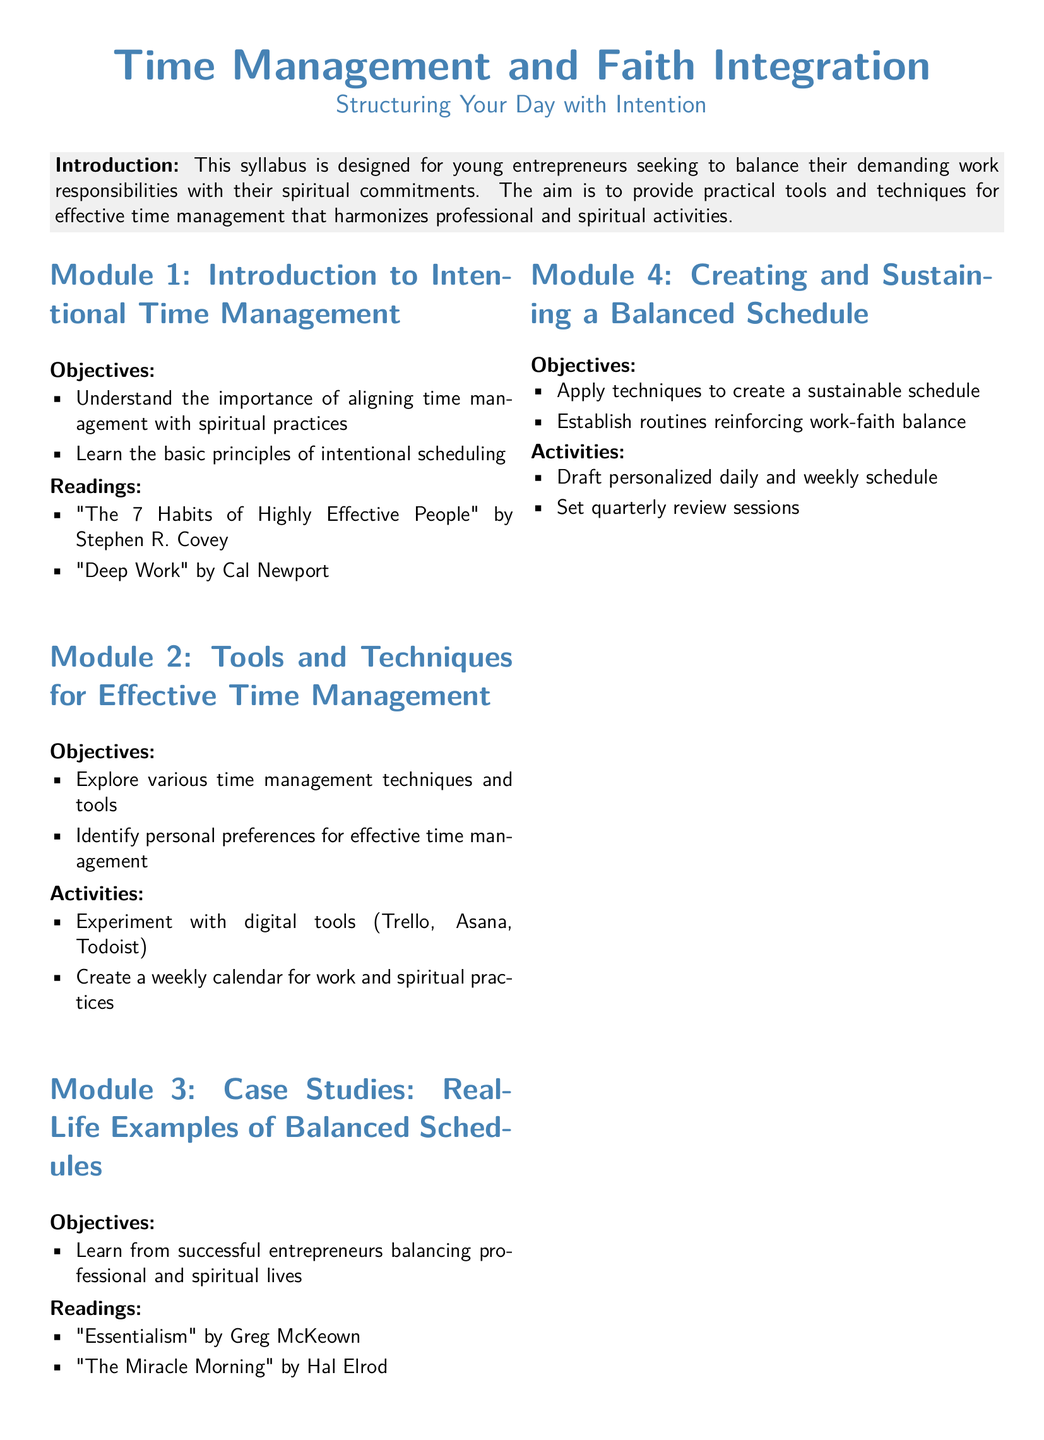what is the title of Module 4? The title is provided in the syllabus under the section headings, which states "Creating and Sustaining a Balanced Schedule."
Answer: Creating and Sustaining a Balanced Schedule how many modules are listed in the syllabus? The syllabus outlines a total of four modules, as indicated by the numbered sections.
Answer: 4 what is one of the objectives of Module 1? The syllabus lists objectives in bullet points for each module, with one objective stating, "Understand the importance of aligning time management with spiritual practices."
Answer: Understand the importance of aligning time management with spiritual practices which reading is suggested for Module 3? The readings for each module are explicitly listed, and one suggested reading for Module 3 is "Essentialism" by Greg McKeown.
Answer: Essentialism what type of activity is included in Module 2? An activity is defined in the syllabus, and one of the activities mentioned for Module 2 is "Experiment with digital tools (Trello, Asana, Todoist)."
Answer: Experiment with digital tools (Trello, Asana, Todoist) what resource is listed for creating a daily schedule? The syllabus provides external resources at the end, including a link for a Daily Schedule Template.
Answer: Daily Schedule Template what is the objective of Module 4 related to routines? The objectives for each module are outlined, and one objective states, "Establish routines reinforcing work-faith balance."
Answer: Establish routines reinforcing work-faith balance what principle is associated with effective scheduling in Module 1? The syllabus mentions the basic principles of intentional scheduling as an objective in Module 1.
Answer: Basic principles of intentional scheduling 